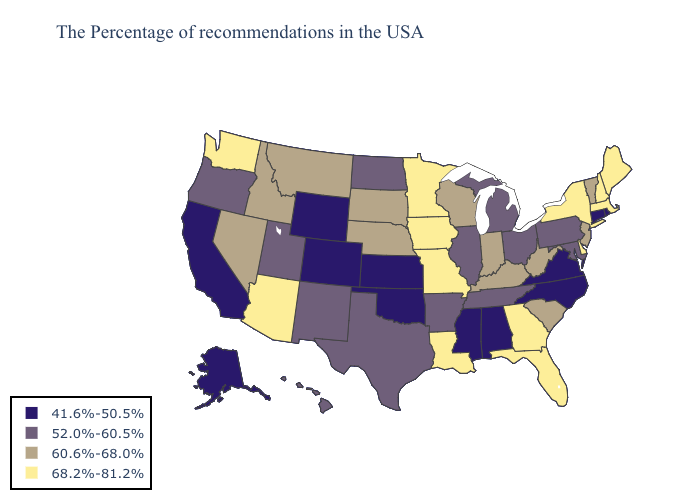Name the states that have a value in the range 68.2%-81.2%?
Be succinct. Maine, Massachusetts, New Hampshire, New York, Delaware, Florida, Georgia, Louisiana, Missouri, Minnesota, Iowa, Arizona, Washington. What is the value of South Carolina?
Answer briefly. 60.6%-68.0%. Does Florida have a lower value than New Jersey?
Give a very brief answer. No. What is the value of Nebraska?
Answer briefly. 60.6%-68.0%. Does Vermont have the same value as Rhode Island?
Short answer required. No. Name the states that have a value in the range 41.6%-50.5%?
Give a very brief answer. Rhode Island, Connecticut, Virginia, North Carolina, Alabama, Mississippi, Kansas, Oklahoma, Wyoming, Colorado, California, Alaska. Name the states that have a value in the range 60.6%-68.0%?
Give a very brief answer. Vermont, New Jersey, South Carolina, West Virginia, Kentucky, Indiana, Wisconsin, Nebraska, South Dakota, Montana, Idaho, Nevada. What is the value of Pennsylvania?
Short answer required. 52.0%-60.5%. Does Kansas have the lowest value in the MidWest?
Concise answer only. Yes. Among the states that border Ohio , does Michigan have the lowest value?
Write a very short answer. Yes. What is the value of South Carolina?
Answer briefly. 60.6%-68.0%. Name the states that have a value in the range 52.0%-60.5%?
Keep it brief. Maryland, Pennsylvania, Ohio, Michigan, Tennessee, Illinois, Arkansas, Texas, North Dakota, New Mexico, Utah, Oregon, Hawaii. Among the states that border Washington , which have the highest value?
Be succinct. Idaho. Does Indiana have a higher value than New York?
Short answer required. No. Which states have the lowest value in the MidWest?
Answer briefly. Kansas. 